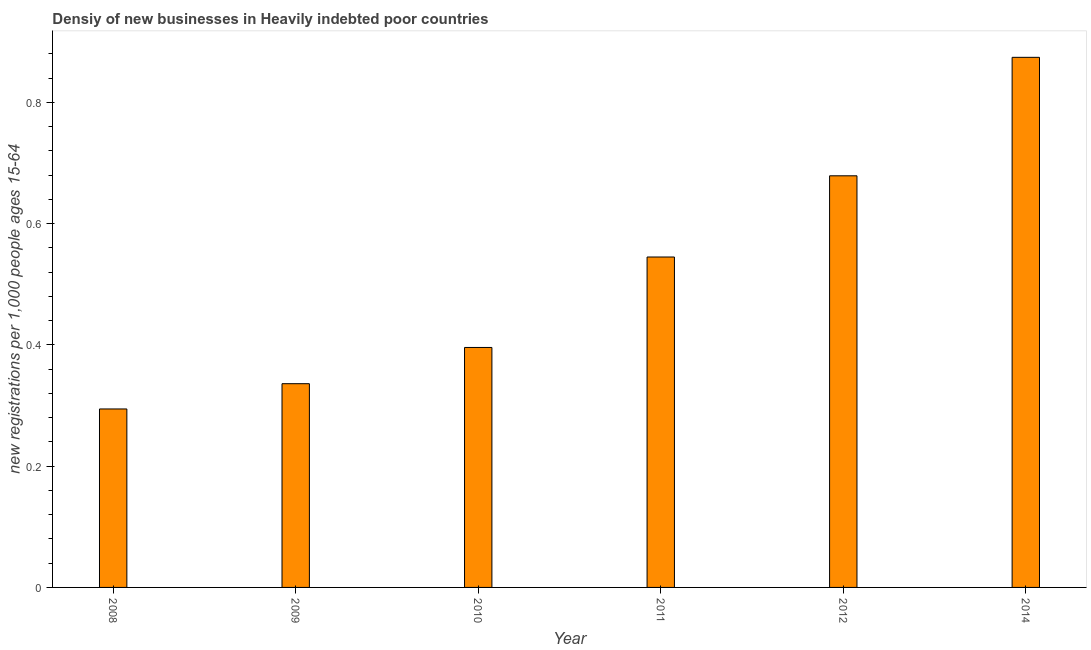Does the graph contain any zero values?
Your response must be concise. No. What is the title of the graph?
Provide a succinct answer. Densiy of new businesses in Heavily indebted poor countries. What is the label or title of the X-axis?
Make the answer very short. Year. What is the label or title of the Y-axis?
Provide a succinct answer. New registrations per 1,0 people ages 15-64. What is the density of new business in 2014?
Your answer should be very brief. 0.87. Across all years, what is the maximum density of new business?
Ensure brevity in your answer.  0.87. Across all years, what is the minimum density of new business?
Offer a terse response. 0.29. In which year was the density of new business minimum?
Provide a succinct answer. 2008. What is the sum of the density of new business?
Make the answer very short. 3.12. What is the difference between the density of new business in 2008 and 2009?
Keep it short and to the point. -0.04. What is the average density of new business per year?
Make the answer very short. 0.52. What is the median density of new business?
Give a very brief answer. 0.47. Do a majority of the years between 2010 and 2012 (inclusive) have density of new business greater than 0.36 ?
Your answer should be very brief. Yes. What is the ratio of the density of new business in 2008 to that in 2011?
Offer a terse response. 0.54. Is the density of new business in 2008 less than that in 2012?
Ensure brevity in your answer.  Yes. What is the difference between the highest and the second highest density of new business?
Your response must be concise. 0.2. What is the difference between the highest and the lowest density of new business?
Your response must be concise. 0.58. What is the new registrations per 1,000 people ages 15-64 in 2008?
Offer a very short reply. 0.29. What is the new registrations per 1,000 people ages 15-64 of 2009?
Your response must be concise. 0.34. What is the new registrations per 1,000 people ages 15-64 of 2010?
Offer a very short reply. 0.4. What is the new registrations per 1,000 people ages 15-64 of 2011?
Give a very brief answer. 0.55. What is the new registrations per 1,000 people ages 15-64 of 2012?
Provide a succinct answer. 0.68. What is the new registrations per 1,000 people ages 15-64 of 2014?
Your response must be concise. 0.87. What is the difference between the new registrations per 1,000 people ages 15-64 in 2008 and 2009?
Your answer should be very brief. -0.04. What is the difference between the new registrations per 1,000 people ages 15-64 in 2008 and 2010?
Offer a terse response. -0.1. What is the difference between the new registrations per 1,000 people ages 15-64 in 2008 and 2011?
Give a very brief answer. -0.25. What is the difference between the new registrations per 1,000 people ages 15-64 in 2008 and 2012?
Make the answer very short. -0.38. What is the difference between the new registrations per 1,000 people ages 15-64 in 2008 and 2014?
Provide a succinct answer. -0.58. What is the difference between the new registrations per 1,000 people ages 15-64 in 2009 and 2010?
Provide a short and direct response. -0.06. What is the difference between the new registrations per 1,000 people ages 15-64 in 2009 and 2011?
Offer a very short reply. -0.21. What is the difference between the new registrations per 1,000 people ages 15-64 in 2009 and 2012?
Offer a terse response. -0.34. What is the difference between the new registrations per 1,000 people ages 15-64 in 2009 and 2014?
Provide a short and direct response. -0.54. What is the difference between the new registrations per 1,000 people ages 15-64 in 2010 and 2011?
Offer a very short reply. -0.15. What is the difference between the new registrations per 1,000 people ages 15-64 in 2010 and 2012?
Make the answer very short. -0.28. What is the difference between the new registrations per 1,000 people ages 15-64 in 2010 and 2014?
Your answer should be very brief. -0.48. What is the difference between the new registrations per 1,000 people ages 15-64 in 2011 and 2012?
Offer a terse response. -0.13. What is the difference between the new registrations per 1,000 people ages 15-64 in 2011 and 2014?
Your answer should be compact. -0.33. What is the difference between the new registrations per 1,000 people ages 15-64 in 2012 and 2014?
Give a very brief answer. -0.2. What is the ratio of the new registrations per 1,000 people ages 15-64 in 2008 to that in 2009?
Offer a terse response. 0.88. What is the ratio of the new registrations per 1,000 people ages 15-64 in 2008 to that in 2010?
Your answer should be compact. 0.74. What is the ratio of the new registrations per 1,000 people ages 15-64 in 2008 to that in 2011?
Make the answer very short. 0.54. What is the ratio of the new registrations per 1,000 people ages 15-64 in 2008 to that in 2012?
Your answer should be very brief. 0.43. What is the ratio of the new registrations per 1,000 people ages 15-64 in 2008 to that in 2014?
Make the answer very short. 0.34. What is the ratio of the new registrations per 1,000 people ages 15-64 in 2009 to that in 2010?
Your response must be concise. 0.85. What is the ratio of the new registrations per 1,000 people ages 15-64 in 2009 to that in 2011?
Offer a very short reply. 0.62. What is the ratio of the new registrations per 1,000 people ages 15-64 in 2009 to that in 2012?
Your response must be concise. 0.49. What is the ratio of the new registrations per 1,000 people ages 15-64 in 2009 to that in 2014?
Make the answer very short. 0.38. What is the ratio of the new registrations per 1,000 people ages 15-64 in 2010 to that in 2011?
Offer a terse response. 0.73. What is the ratio of the new registrations per 1,000 people ages 15-64 in 2010 to that in 2012?
Give a very brief answer. 0.58. What is the ratio of the new registrations per 1,000 people ages 15-64 in 2010 to that in 2014?
Your answer should be very brief. 0.45. What is the ratio of the new registrations per 1,000 people ages 15-64 in 2011 to that in 2012?
Keep it short and to the point. 0.8. What is the ratio of the new registrations per 1,000 people ages 15-64 in 2011 to that in 2014?
Your response must be concise. 0.62. What is the ratio of the new registrations per 1,000 people ages 15-64 in 2012 to that in 2014?
Your response must be concise. 0.78. 